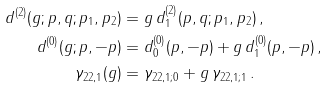Convert formula to latex. <formula><loc_0><loc_0><loc_500><loc_500>d ^ { ( 2 ) } ( g ; p , q ; p _ { 1 } , p _ { 2 } ) & = g \, d _ { 1 } ^ { ( 2 ) } ( p , q ; p _ { 1 } , p _ { 2 } ) \, , \\ d ^ { ( 0 ) } ( g ; p , - p ) & = d _ { 0 } ^ { ( 0 ) } ( p , - p ) + g \, d _ { 1 } ^ { ( 0 ) } ( p , - p ) \, , \\ \gamma _ { 2 2 , 1 } ( g ) & = \gamma _ { 2 2 , 1 ; 0 } + g \, \gamma _ { 2 2 , 1 ; 1 } \, .</formula> 